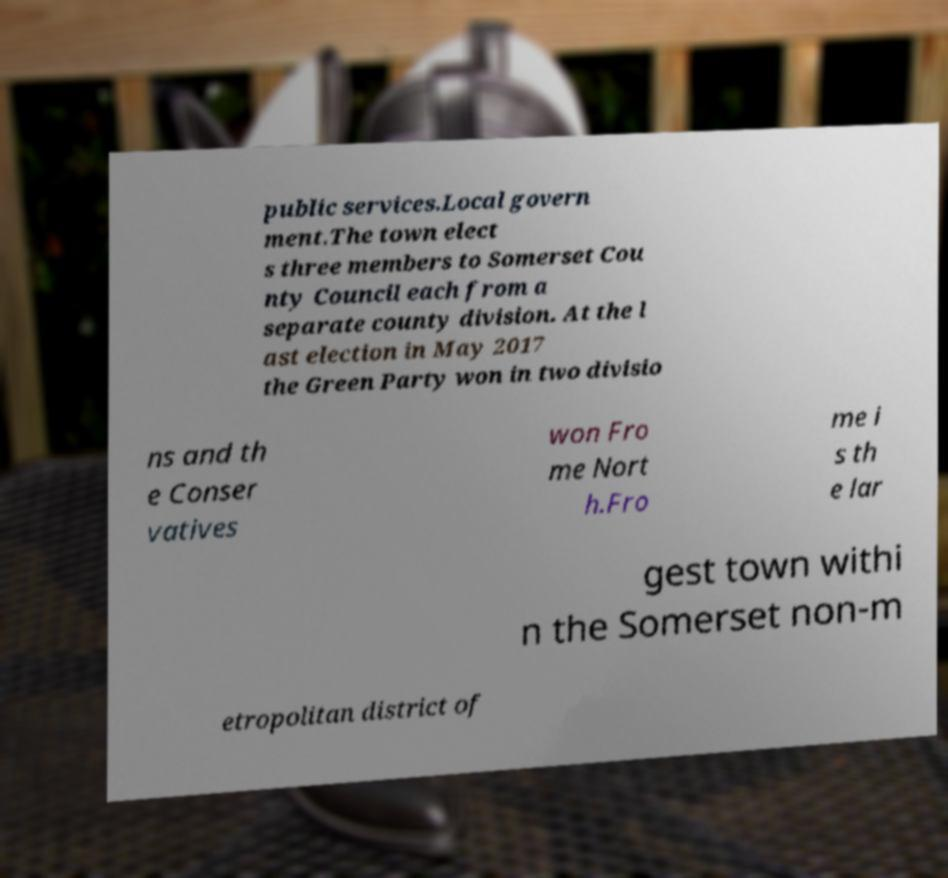What messages or text are displayed in this image? I need them in a readable, typed format. public services.Local govern ment.The town elect s three members to Somerset Cou nty Council each from a separate county division. At the l ast election in May 2017 the Green Party won in two divisio ns and th e Conser vatives won Fro me Nort h.Fro me i s th e lar gest town withi n the Somerset non-m etropolitan district of 